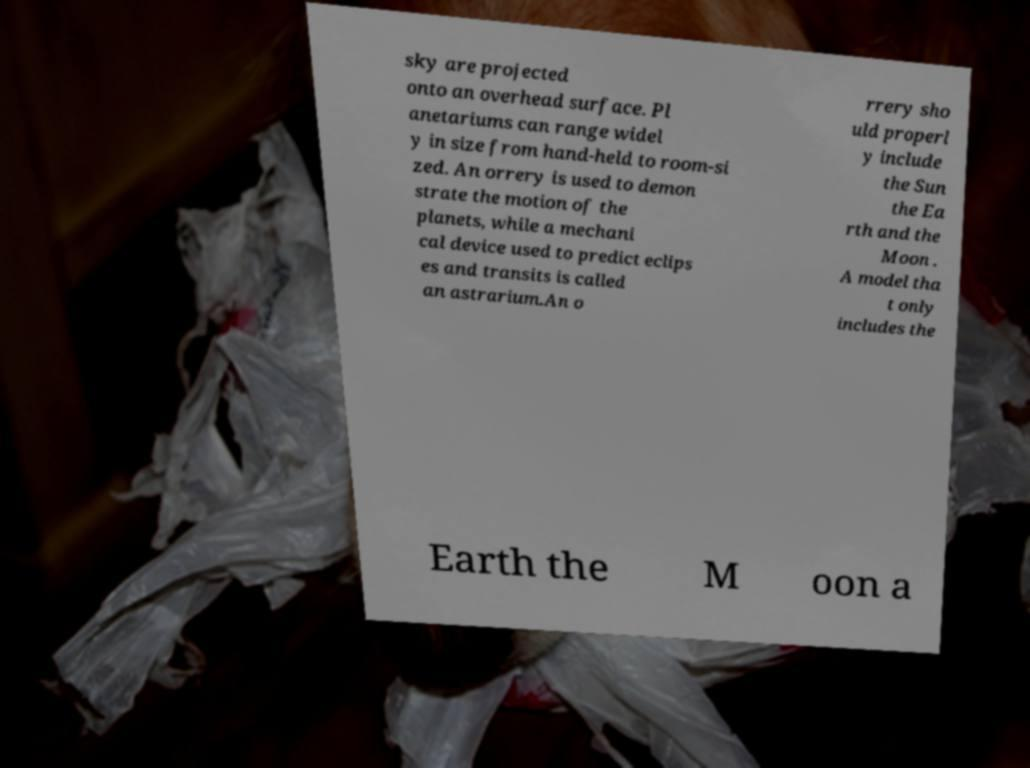I need the written content from this picture converted into text. Can you do that? sky are projected onto an overhead surface. Pl anetariums can range widel y in size from hand-held to room-si zed. An orrery is used to demon strate the motion of the planets, while a mechani cal device used to predict eclips es and transits is called an astrarium.An o rrery sho uld properl y include the Sun the Ea rth and the Moon . A model tha t only includes the Earth the M oon a 